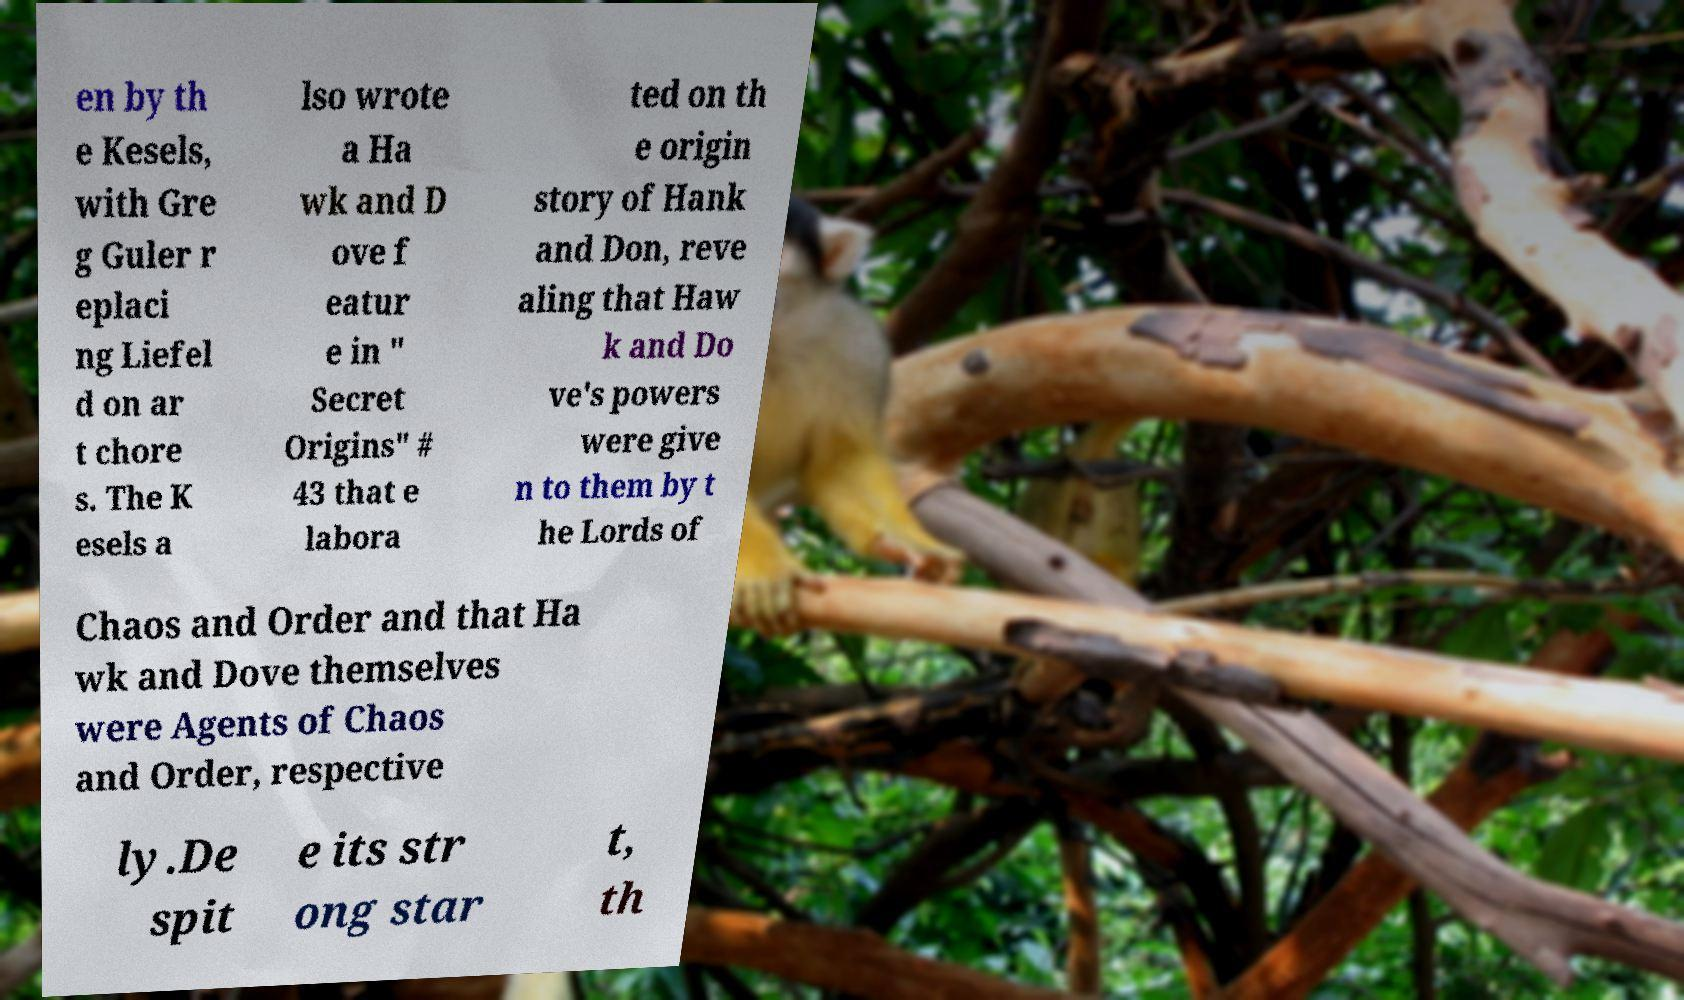There's text embedded in this image that I need extracted. Can you transcribe it verbatim? en by th e Kesels, with Gre g Guler r eplaci ng Liefel d on ar t chore s. The K esels a lso wrote a Ha wk and D ove f eatur e in " Secret Origins" # 43 that e labora ted on th e origin story of Hank and Don, reve aling that Haw k and Do ve's powers were give n to them by t he Lords of Chaos and Order and that Ha wk and Dove themselves were Agents of Chaos and Order, respective ly.De spit e its str ong star t, th 